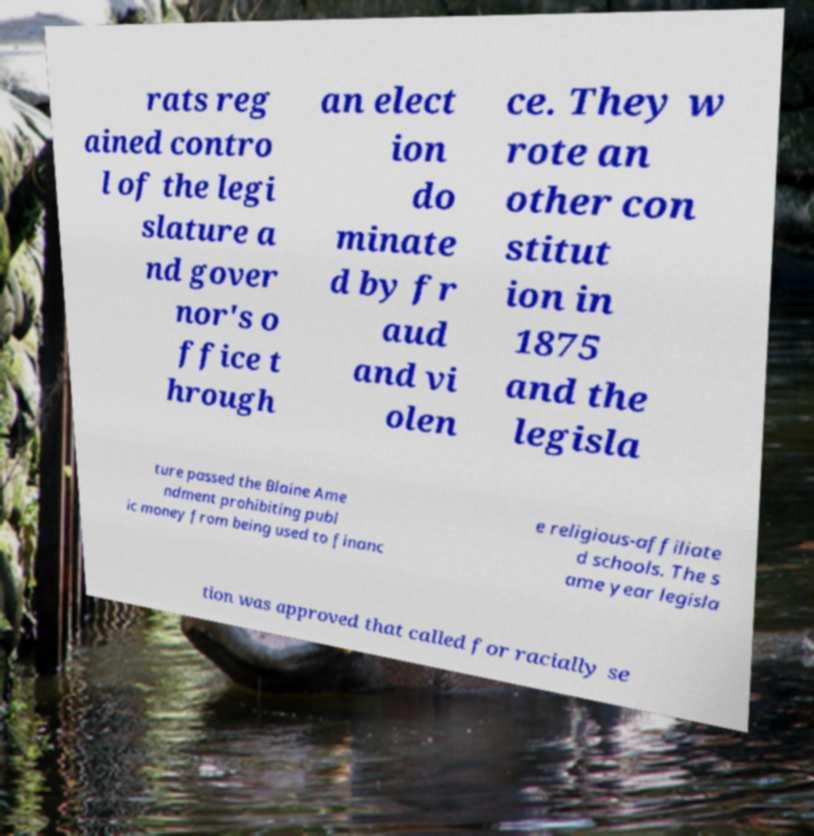Could you extract and type out the text from this image? rats reg ained contro l of the legi slature a nd gover nor's o ffice t hrough an elect ion do minate d by fr aud and vi olen ce. They w rote an other con stitut ion in 1875 and the legisla ture passed the Blaine Ame ndment prohibiting publ ic money from being used to financ e religious-affiliate d schools. The s ame year legisla tion was approved that called for racially se 